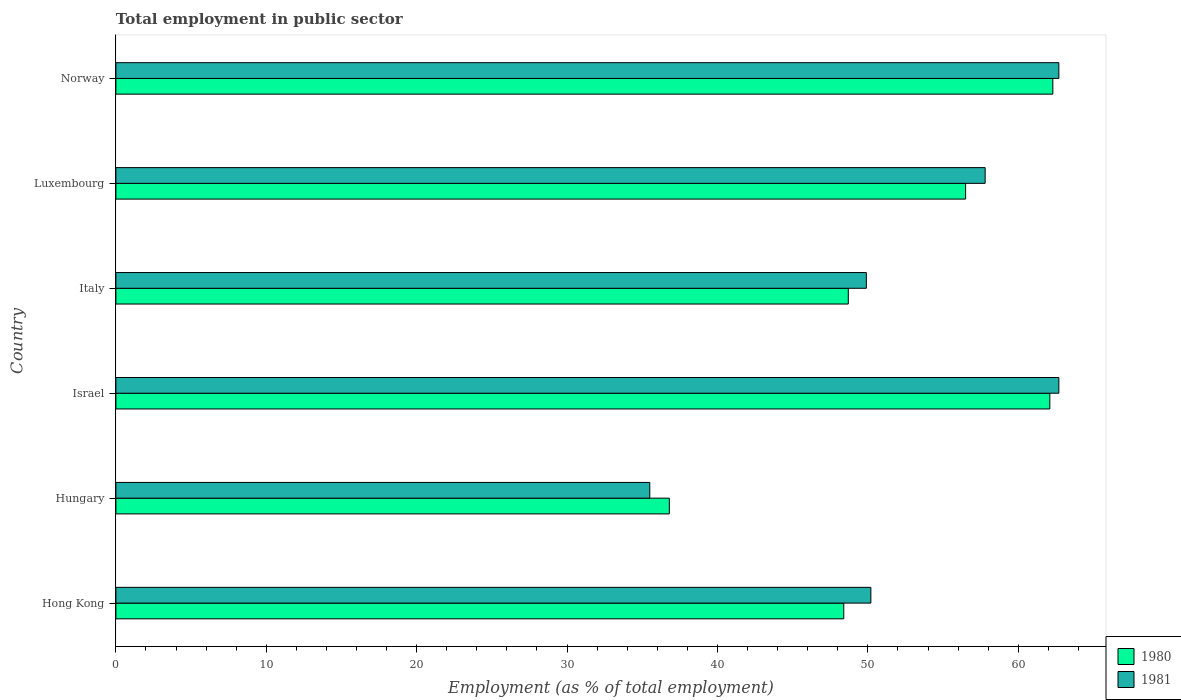How many different coloured bars are there?
Your response must be concise. 2. Are the number of bars per tick equal to the number of legend labels?
Keep it short and to the point. Yes. Are the number of bars on each tick of the Y-axis equal?
Your answer should be very brief. Yes. How many bars are there on the 3rd tick from the top?
Give a very brief answer. 2. What is the label of the 4th group of bars from the top?
Your answer should be compact. Israel. In how many cases, is the number of bars for a given country not equal to the number of legend labels?
Your answer should be very brief. 0. What is the employment in public sector in 1980 in Hong Kong?
Provide a succinct answer. 48.4. Across all countries, what is the maximum employment in public sector in 1980?
Offer a terse response. 62.3. Across all countries, what is the minimum employment in public sector in 1981?
Offer a terse response. 35.5. In which country was the employment in public sector in 1980 minimum?
Give a very brief answer. Hungary. What is the total employment in public sector in 1980 in the graph?
Make the answer very short. 314.8. What is the difference between the employment in public sector in 1980 in Israel and that in Norway?
Your answer should be compact. -0.2. What is the average employment in public sector in 1980 per country?
Give a very brief answer. 52.47. What is the difference between the employment in public sector in 1980 and employment in public sector in 1981 in Italy?
Provide a short and direct response. -1.2. What is the ratio of the employment in public sector in 1980 in Hong Kong to that in Italy?
Your answer should be compact. 0.99. Is the employment in public sector in 1980 in Hong Kong less than that in Norway?
Provide a succinct answer. Yes. Is the difference between the employment in public sector in 1980 in Hungary and Israel greater than the difference between the employment in public sector in 1981 in Hungary and Israel?
Provide a succinct answer. Yes. What is the difference between the highest and the lowest employment in public sector in 1981?
Offer a very short reply. 27.2. What does the 1st bar from the top in Norway represents?
Keep it short and to the point. 1981. What does the 1st bar from the bottom in Hungary represents?
Make the answer very short. 1980. Are all the bars in the graph horizontal?
Offer a terse response. Yes. Are the values on the major ticks of X-axis written in scientific E-notation?
Your answer should be very brief. No. Does the graph contain grids?
Provide a short and direct response. No. How many legend labels are there?
Your answer should be very brief. 2. What is the title of the graph?
Provide a short and direct response. Total employment in public sector. What is the label or title of the X-axis?
Your response must be concise. Employment (as % of total employment). What is the label or title of the Y-axis?
Offer a very short reply. Country. What is the Employment (as % of total employment) of 1980 in Hong Kong?
Ensure brevity in your answer.  48.4. What is the Employment (as % of total employment) in 1981 in Hong Kong?
Offer a very short reply. 50.2. What is the Employment (as % of total employment) of 1980 in Hungary?
Make the answer very short. 36.8. What is the Employment (as % of total employment) of 1981 in Hungary?
Make the answer very short. 35.5. What is the Employment (as % of total employment) in 1980 in Israel?
Provide a short and direct response. 62.1. What is the Employment (as % of total employment) in 1981 in Israel?
Offer a terse response. 62.7. What is the Employment (as % of total employment) in 1980 in Italy?
Offer a very short reply. 48.7. What is the Employment (as % of total employment) of 1981 in Italy?
Offer a terse response. 49.9. What is the Employment (as % of total employment) in 1980 in Luxembourg?
Provide a short and direct response. 56.5. What is the Employment (as % of total employment) in 1981 in Luxembourg?
Give a very brief answer. 57.8. What is the Employment (as % of total employment) in 1980 in Norway?
Make the answer very short. 62.3. What is the Employment (as % of total employment) of 1981 in Norway?
Make the answer very short. 62.7. Across all countries, what is the maximum Employment (as % of total employment) in 1980?
Provide a short and direct response. 62.3. Across all countries, what is the maximum Employment (as % of total employment) in 1981?
Offer a very short reply. 62.7. Across all countries, what is the minimum Employment (as % of total employment) in 1980?
Your answer should be very brief. 36.8. Across all countries, what is the minimum Employment (as % of total employment) in 1981?
Make the answer very short. 35.5. What is the total Employment (as % of total employment) of 1980 in the graph?
Ensure brevity in your answer.  314.8. What is the total Employment (as % of total employment) in 1981 in the graph?
Offer a terse response. 318.8. What is the difference between the Employment (as % of total employment) in 1981 in Hong Kong and that in Hungary?
Keep it short and to the point. 14.7. What is the difference between the Employment (as % of total employment) in 1980 in Hong Kong and that in Israel?
Keep it short and to the point. -13.7. What is the difference between the Employment (as % of total employment) in 1981 in Hong Kong and that in Israel?
Provide a short and direct response. -12.5. What is the difference between the Employment (as % of total employment) of 1981 in Hong Kong and that in Italy?
Offer a terse response. 0.3. What is the difference between the Employment (as % of total employment) in 1980 in Hong Kong and that in Luxembourg?
Keep it short and to the point. -8.1. What is the difference between the Employment (as % of total employment) of 1980 in Hong Kong and that in Norway?
Your response must be concise. -13.9. What is the difference between the Employment (as % of total employment) of 1981 in Hong Kong and that in Norway?
Offer a terse response. -12.5. What is the difference between the Employment (as % of total employment) in 1980 in Hungary and that in Israel?
Offer a very short reply. -25.3. What is the difference between the Employment (as % of total employment) of 1981 in Hungary and that in Israel?
Your answer should be very brief. -27.2. What is the difference between the Employment (as % of total employment) of 1981 in Hungary and that in Italy?
Provide a short and direct response. -14.4. What is the difference between the Employment (as % of total employment) of 1980 in Hungary and that in Luxembourg?
Offer a very short reply. -19.7. What is the difference between the Employment (as % of total employment) in 1981 in Hungary and that in Luxembourg?
Offer a terse response. -22.3. What is the difference between the Employment (as % of total employment) of 1980 in Hungary and that in Norway?
Make the answer very short. -25.5. What is the difference between the Employment (as % of total employment) in 1981 in Hungary and that in Norway?
Offer a terse response. -27.2. What is the difference between the Employment (as % of total employment) of 1980 in Israel and that in Italy?
Your answer should be compact. 13.4. What is the difference between the Employment (as % of total employment) of 1981 in Israel and that in Italy?
Offer a terse response. 12.8. What is the difference between the Employment (as % of total employment) in 1981 in Israel and that in Luxembourg?
Keep it short and to the point. 4.9. What is the difference between the Employment (as % of total employment) in 1981 in Israel and that in Norway?
Give a very brief answer. 0. What is the difference between the Employment (as % of total employment) of 1980 in Luxembourg and that in Norway?
Keep it short and to the point. -5.8. What is the difference between the Employment (as % of total employment) of 1980 in Hong Kong and the Employment (as % of total employment) of 1981 in Hungary?
Ensure brevity in your answer.  12.9. What is the difference between the Employment (as % of total employment) in 1980 in Hong Kong and the Employment (as % of total employment) in 1981 in Israel?
Your answer should be very brief. -14.3. What is the difference between the Employment (as % of total employment) of 1980 in Hong Kong and the Employment (as % of total employment) of 1981 in Italy?
Provide a short and direct response. -1.5. What is the difference between the Employment (as % of total employment) of 1980 in Hong Kong and the Employment (as % of total employment) of 1981 in Luxembourg?
Provide a short and direct response. -9.4. What is the difference between the Employment (as % of total employment) of 1980 in Hong Kong and the Employment (as % of total employment) of 1981 in Norway?
Give a very brief answer. -14.3. What is the difference between the Employment (as % of total employment) in 1980 in Hungary and the Employment (as % of total employment) in 1981 in Israel?
Make the answer very short. -25.9. What is the difference between the Employment (as % of total employment) in 1980 in Hungary and the Employment (as % of total employment) in 1981 in Italy?
Offer a terse response. -13.1. What is the difference between the Employment (as % of total employment) in 1980 in Hungary and the Employment (as % of total employment) in 1981 in Luxembourg?
Offer a very short reply. -21. What is the difference between the Employment (as % of total employment) of 1980 in Hungary and the Employment (as % of total employment) of 1981 in Norway?
Provide a short and direct response. -25.9. What is the difference between the Employment (as % of total employment) in 1980 in Israel and the Employment (as % of total employment) in 1981 in Norway?
Give a very brief answer. -0.6. What is the difference between the Employment (as % of total employment) of 1980 in Italy and the Employment (as % of total employment) of 1981 in Luxembourg?
Your response must be concise. -9.1. What is the difference between the Employment (as % of total employment) of 1980 in Italy and the Employment (as % of total employment) of 1981 in Norway?
Keep it short and to the point. -14. What is the difference between the Employment (as % of total employment) of 1980 in Luxembourg and the Employment (as % of total employment) of 1981 in Norway?
Give a very brief answer. -6.2. What is the average Employment (as % of total employment) of 1980 per country?
Your answer should be compact. 52.47. What is the average Employment (as % of total employment) of 1981 per country?
Ensure brevity in your answer.  53.13. What is the difference between the Employment (as % of total employment) in 1980 and Employment (as % of total employment) in 1981 in Hong Kong?
Provide a short and direct response. -1.8. What is the difference between the Employment (as % of total employment) of 1980 and Employment (as % of total employment) of 1981 in Israel?
Ensure brevity in your answer.  -0.6. What is the difference between the Employment (as % of total employment) of 1980 and Employment (as % of total employment) of 1981 in Italy?
Ensure brevity in your answer.  -1.2. What is the difference between the Employment (as % of total employment) of 1980 and Employment (as % of total employment) of 1981 in Luxembourg?
Keep it short and to the point. -1.3. What is the ratio of the Employment (as % of total employment) of 1980 in Hong Kong to that in Hungary?
Provide a succinct answer. 1.32. What is the ratio of the Employment (as % of total employment) in 1981 in Hong Kong to that in Hungary?
Make the answer very short. 1.41. What is the ratio of the Employment (as % of total employment) of 1980 in Hong Kong to that in Israel?
Keep it short and to the point. 0.78. What is the ratio of the Employment (as % of total employment) in 1981 in Hong Kong to that in Israel?
Provide a short and direct response. 0.8. What is the ratio of the Employment (as % of total employment) of 1980 in Hong Kong to that in Italy?
Provide a succinct answer. 0.99. What is the ratio of the Employment (as % of total employment) in 1981 in Hong Kong to that in Italy?
Ensure brevity in your answer.  1.01. What is the ratio of the Employment (as % of total employment) of 1980 in Hong Kong to that in Luxembourg?
Make the answer very short. 0.86. What is the ratio of the Employment (as % of total employment) in 1981 in Hong Kong to that in Luxembourg?
Ensure brevity in your answer.  0.87. What is the ratio of the Employment (as % of total employment) of 1980 in Hong Kong to that in Norway?
Your response must be concise. 0.78. What is the ratio of the Employment (as % of total employment) of 1981 in Hong Kong to that in Norway?
Provide a short and direct response. 0.8. What is the ratio of the Employment (as % of total employment) of 1980 in Hungary to that in Israel?
Give a very brief answer. 0.59. What is the ratio of the Employment (as % of total employment) of 1981 in Hungary to that in Israel?
Provide a succinct answer. 0.57. What is the ratio of the Employment (as % of total employment) of 1980 in Hungary to that in Italy?
Provide a short and direct response. 0.76. What is the ratio of the Employment (as % of total employment) of 1981 in Hungary to that in Italy?
Offer a very short reply. 0.71. What is the ratio of the Employment (as % of total employment) in 1980 in Hungary to that in Luxembourg?
Your response must be concise. 0.65. What is the ratio of the Employment (as % of total employment) of 1981 in Hungary to that in Luxembourg?
Make the answer very short. 0.61. What is the ratio of the Employment (as % of total employment) of 1980 in Hungary to that in Norway?
Provide a succinct answer. 0.59. What is the ratio of the Employment (as % of total employment) of 1981 in Hungary to that in Norway?
Offer a terse response. 0.57. What is the ratio of the Employment (as % of total employment) in 1980 in Israel to that in Italy?
Keep it short and to the point. 1.28. What is the ratio of the Employment (as % of total employment) in 1981 in Israel to that in Italy?
Your response must be concise. 1.26. What is the ratio of the Employment (as % of total employment) in 1980 in Israel to that in Luxembourg?
Provide a succinct answer. 1.1. What is the ratio of the Employment (as % of total employment) in 1981 in Israel to that in Luxembourg?
Provide a succinct answer. 1.08. What is the ratio of the Employment (as % of total employment) in 1980 in Israel to that in Norway?
Provide a succinct answer. 1. What is the ratio of the Employment (as % of total employment) in 1980 in Italy to that in Luxembourg?
Your answer should be very brief. 0.86. What is the ratio of the Employment (as % of total employment) of 1981 in Italy to that in Luxembourg?
Provide a short and direct response. 0.86. What is the ratio of the Employment (as % of total employment) in 1980 in Italy to that in Norway?
Ensure brevity in your answer.  0.78. What is the ratio of the Employment (as % of total employment) of 1981 in Italy to that in Norway?
Your response must be concise. 0.8. What is the ratio of the Employment (as % of total employment) in 1980 in Luxembourg to that in Norway?
Your response must be concise. 0.91. What is the ratio of the Employment (as % of total employment) of 1981 in Luxembourg to that in Norway?
Your response must be concise. 0.92. What is the difference between the highest and the second highest Employment (as % of total employment) of 1980?
Your answer should be very brief. 0.2. What is the difference between the highest and the second highest Employment (as % of total employment) in 1981?
Offer a very short reply. 0. What is the difference between the highest and the lowest Employment (as % of total employment) of 1980?
Give a very brief answer. 25.5. What is the difference between the highest and the lowest Employment (as % of total employment) in 1981?
Offer a very short reply. 27.2. 